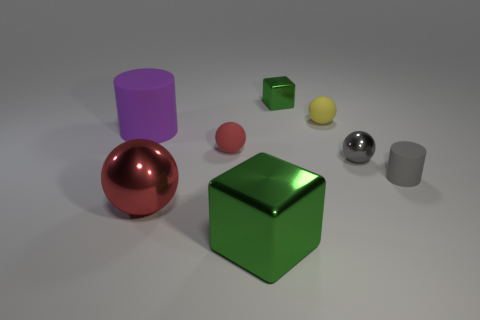How many objects are big gray shiny blocks or things that are in front of the small red rubber sphere? There are three objects that can be considered big, gray, and shiny blocks in the image; however, none are specifically in front of the small red rubber sphere from this perspective. 